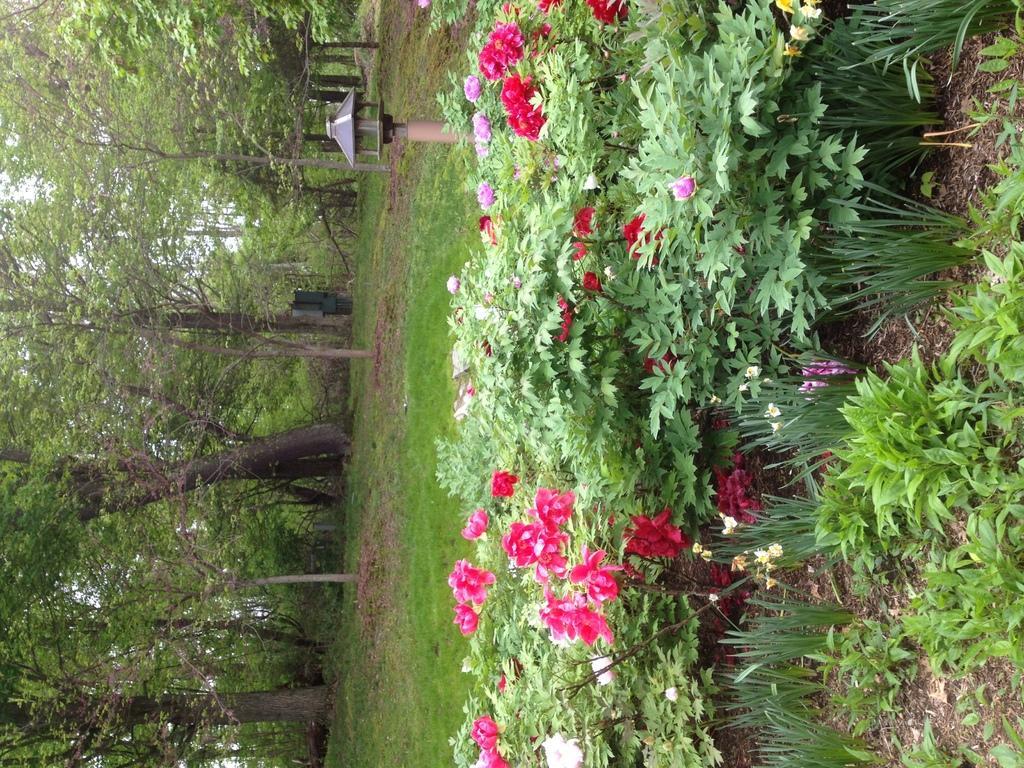Could you give a brief overview of what you see in this image? In this picture I can see flower plants. I can see green grass. I can see trees. 